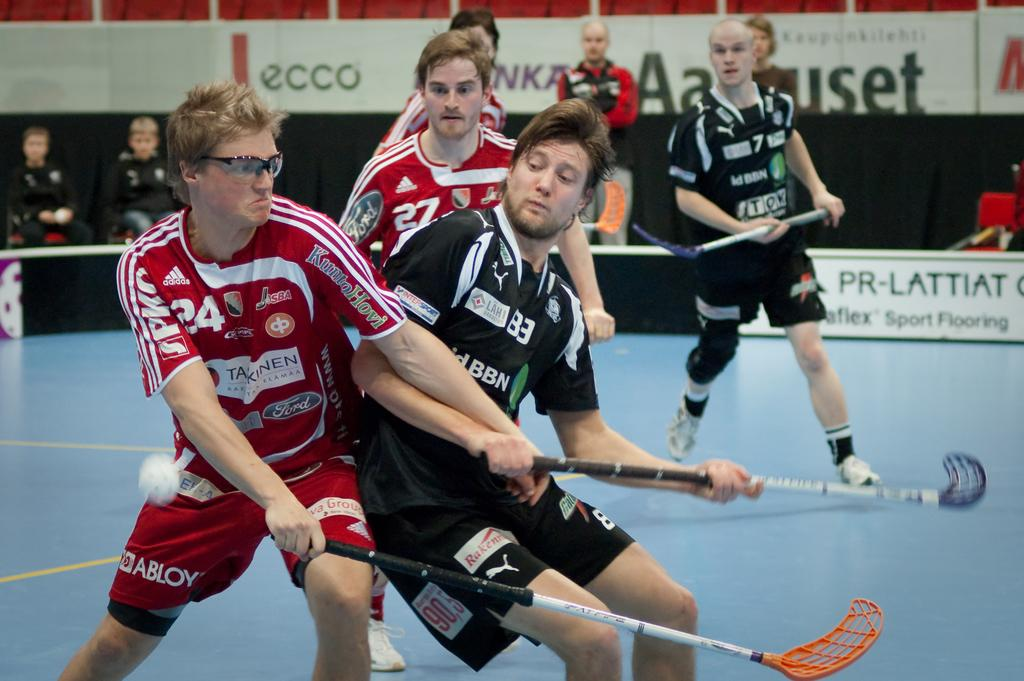What sport are the persons playing in the image? The persons are playing hockey in the image. Where is the hockey game taking place? The hockey game is taking place on the ground. What can be seen in the background of the image? There are chairs, persons, and advertisements in the background of the image. How do the players rub the puck during the game in the image? There is no indication in the image that the players are rubbing the puck; they are playing hockey by hitting the puck with their sticks. 